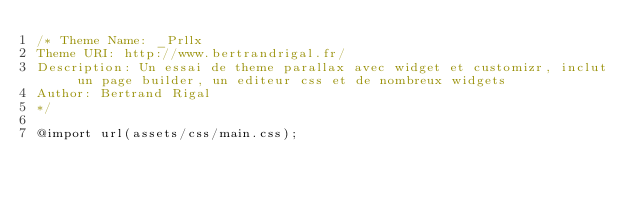Convert code to text. <code><loc_0><loc_0><loc_500><loc_500><_CSS_>/* Theme Name: _Prllx
Theme URI: http://www.bertrandrigal.fr/
Description: Un essai de theme parallax avec widget et customizr, inclut un page builder, un editeur css et de nombreux widgets
Author: Bertrand Rigal
*/

@import url(assets/css/main.css);
</code> 